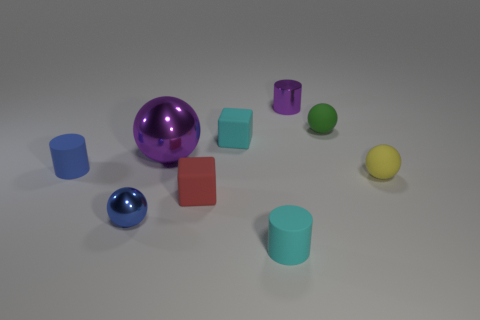Subtract 1 blocks. How many blocks are left? 1 Add 4 small matte objects. How many small matte objects exist? 10 Add 1 tiny purple metal cylinders. How many objects exist? 10 Subtract all green balls. How many balls are left? 3 Subtract all matte cylinders. How many cylinders are left? 1 Subtract 1 purple cylinders. How many objects are left? 8 Subtract all cylinders. How many objects are left? 6 Subtract all cyan cylinders. Subtract all brown balls. How many cylinders are left? 2 Subtract all gray spheres. How many cyan cylinders are left? 1 Subtract all tiny rubber things. Subtract all small gray spheres. How many objects are left? 3 